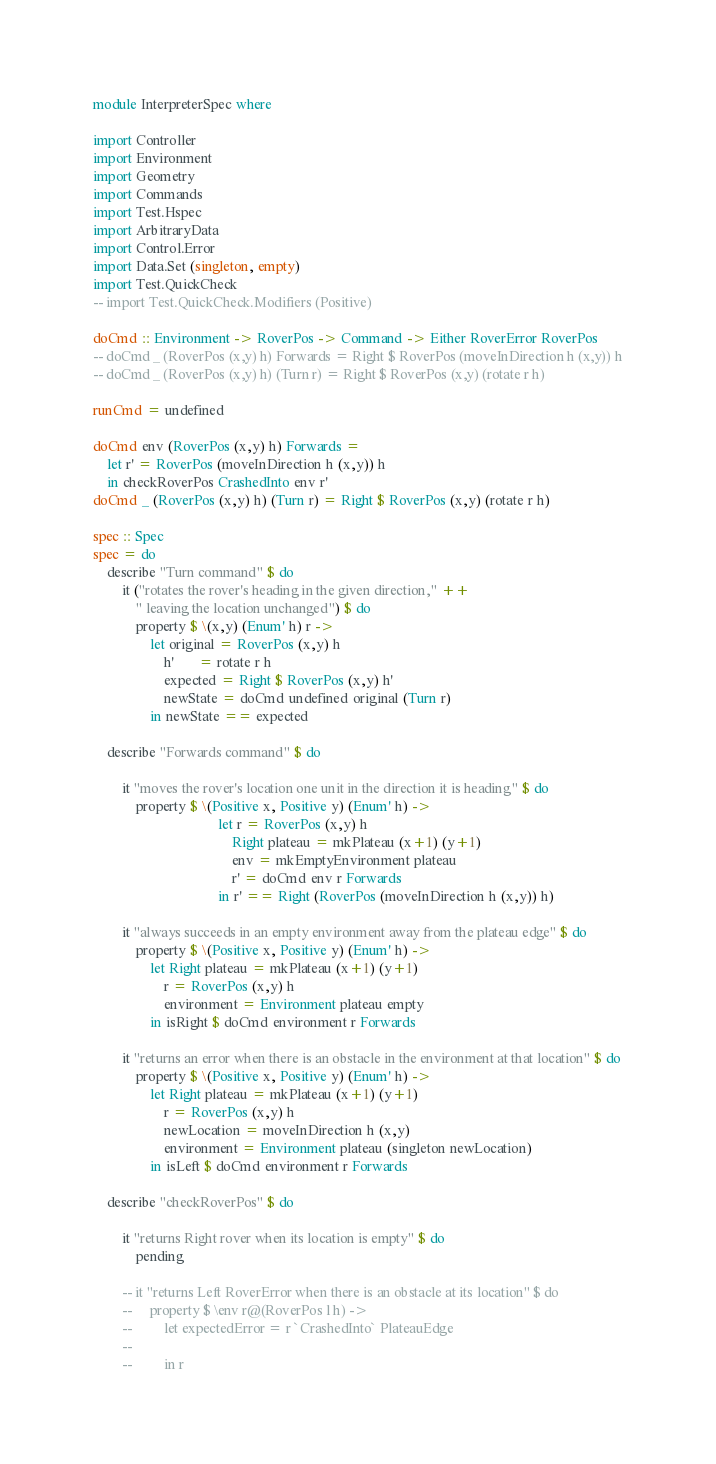<code> <loc_0><loc_0><loc_500><loc_500><_Haskell_>module InterpreterSpec where

import Controller
import Environment
import Geometry
import Commands
import Test.Hspec
import ArbitraryData
import Control.Error
import Data.Set (singleton, empty)
import Test.QuickCheck
-- import Test.QuickCheck.Modifiers (Positive)

doCmd :: Environment -> RoverPos -> Command -> Either RoverError RoverPos
-- doCmd _ (RoverPos (x,y) h) Forwards = Right $ RoverPos (moveInDirection h (x,y)) h
-- doCmd _ (RoverPos (x,y) h) (Turn r) = Right $ RoverPos (x,y) (rotate r h)

runCmd = undefined

doCmd env (RoverPos (x,y) h) Forwards =
    let r' = RoverPos (moveInDirection h (x,y)) h
    in checkRoverPos CrashedInto env r'
doCmd _ (RoverPos (x,y) h) (Turn r) = Right $ RoverPos (x,y) (rotate r h)

spec :: Spec
spec = do
    describe "Turn command" $ do
        it ("rotates the rover's heading in the given direction," ++
            " leaving the location unchanged") $ do
            property $ \(x,y) (Enum' h) r ->
                let original = RoverPos (x,y) h
                    h'       = rotate r h
                    expected = Right $ RoverPos (x,y) h'
                    newState = doCmd undefined original (Turn r)
                in newState == expected

    describe "Forwards command" $ do

        it "moves the rover's location one unit in the direction it is heading" $ do
            property $ \(Positive x, Positive y) (Enum' h) ->
                                   let r = RoverPos (x,y) h
                                       Right plateau = mkPlateau (x+1) (y+1)
                                       env = mkEmptyEnvironment plateau
                                       r' = doCmd env r Forwards
                                   in r' == Right (RoverPos (moveInDirection h (x,y)) h)

        it "always succeeds in an empty environment away from the plateau edge" $ do
            property $ \(Positive x, Positive y) (Enum' h) ->
                let Right plateau = mkPlateau (x+1) (y+1)
                    r = RoverPos (x,y) h
                    environment = Environment plateau empty
                in isRight $ doCmd environment r Forwards

        it "returns an error when there is an obstacle in the environment at that location" $ do
            property $ \(Positive x, Positive y) (Enum' h) ->
                let Right plateau = mkPlateau (x+1) (y+1)
                    r = RoverPos (x,y) h
                    newLocation = moveInDirection h (x,y)
                    environment = Environment plateau (singleton newLocation)
                in isLeft $ doCmd environment r Forwards

    describe "checkRoverPos" $ do

        it "returns Right rover when its location is empty" $ do
            pending

        -- it "returns Left RoverError when there is an obstacle at its location" $ do
        --     property $ \env r@(RoverPos l h) ->
        --         let expectedError = r `CrashedInto` PlateauEdge
        --
        --         in r
</code> 